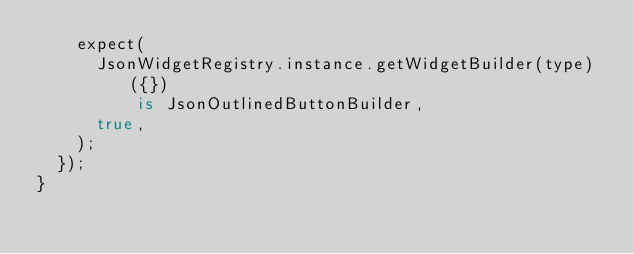Convert code to text. <code><loc_0><loc_0><loc_500><loc_500><_Dart_>    expect(
      JsonWidgetRegistry.instance.getWidgetBuilder(type)({})
          is JsonOutlinedButtonBuilder,
      true,
    );
  });
}
</code> 